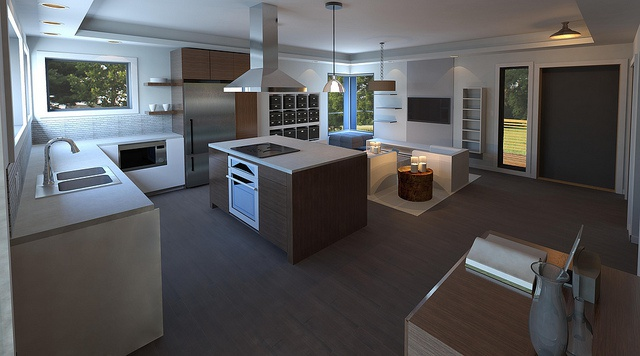Describe the objects in this image and their specific colors. I can see refrigerator in gray, black, and purple tones, vase in gray, black, and darkblue tones, book in gray and lightblue tones, oven in gray, lightblue, and black tones, and sink in gray, darkgray, and lightblue tones in this image. 